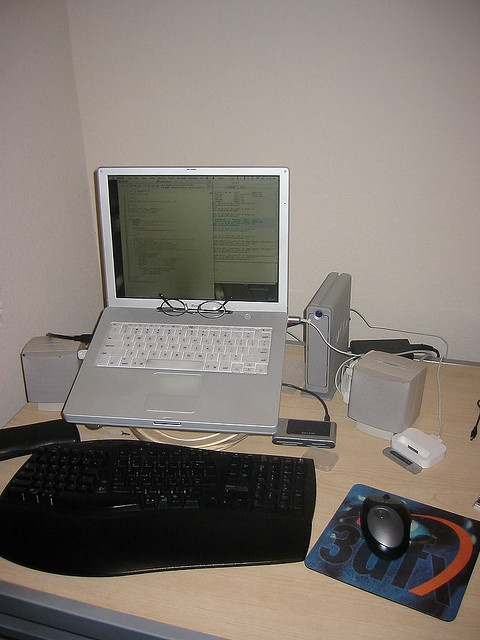Describe the objects in this image and their specific colors. I can see laptop in gray, darkgray, darkgreen, and lightgray tones, keyboard in gray, black, and darkgray tones, keyboard in gray, darkgray, and lightgray tones, and mouse in gray, black, and darkgray tones in this image. 